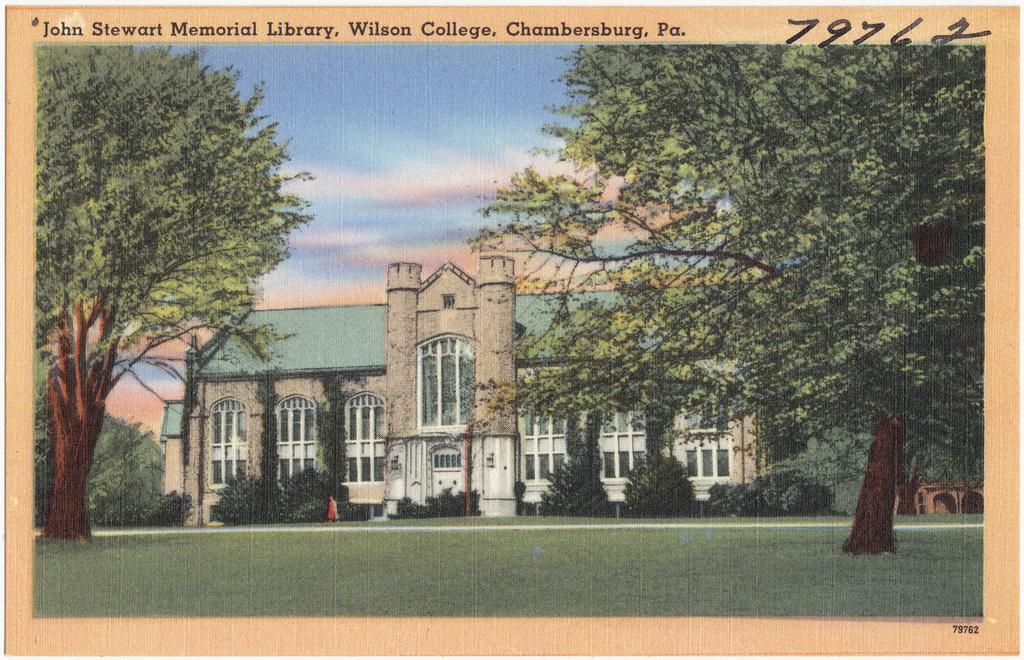Describe this image in one or two sentences. In this image there is a building in middle of this image and there are some trees at left side of this image and right side of this image as well and there is a sky in the background and there is a written text at top of this image. 